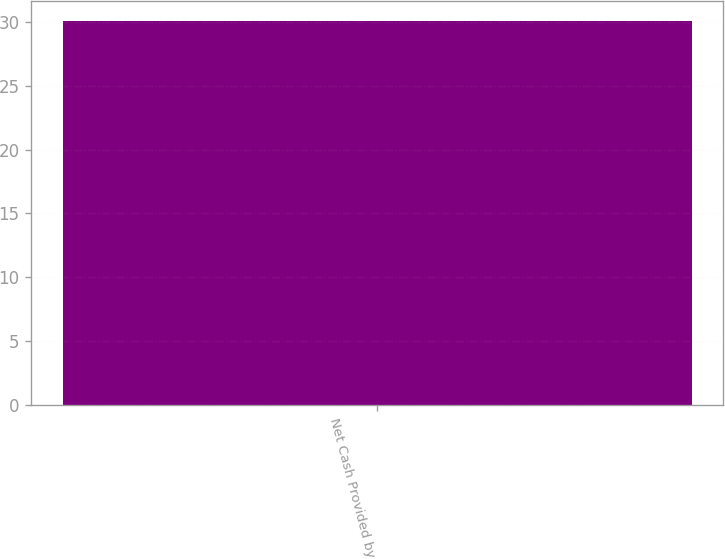<chart> <loc_0><loc_0><loc_500><loc_500><bar_chart><fcel>Net Cash Provided by<nl><fcel>30.1<nl></chart> 